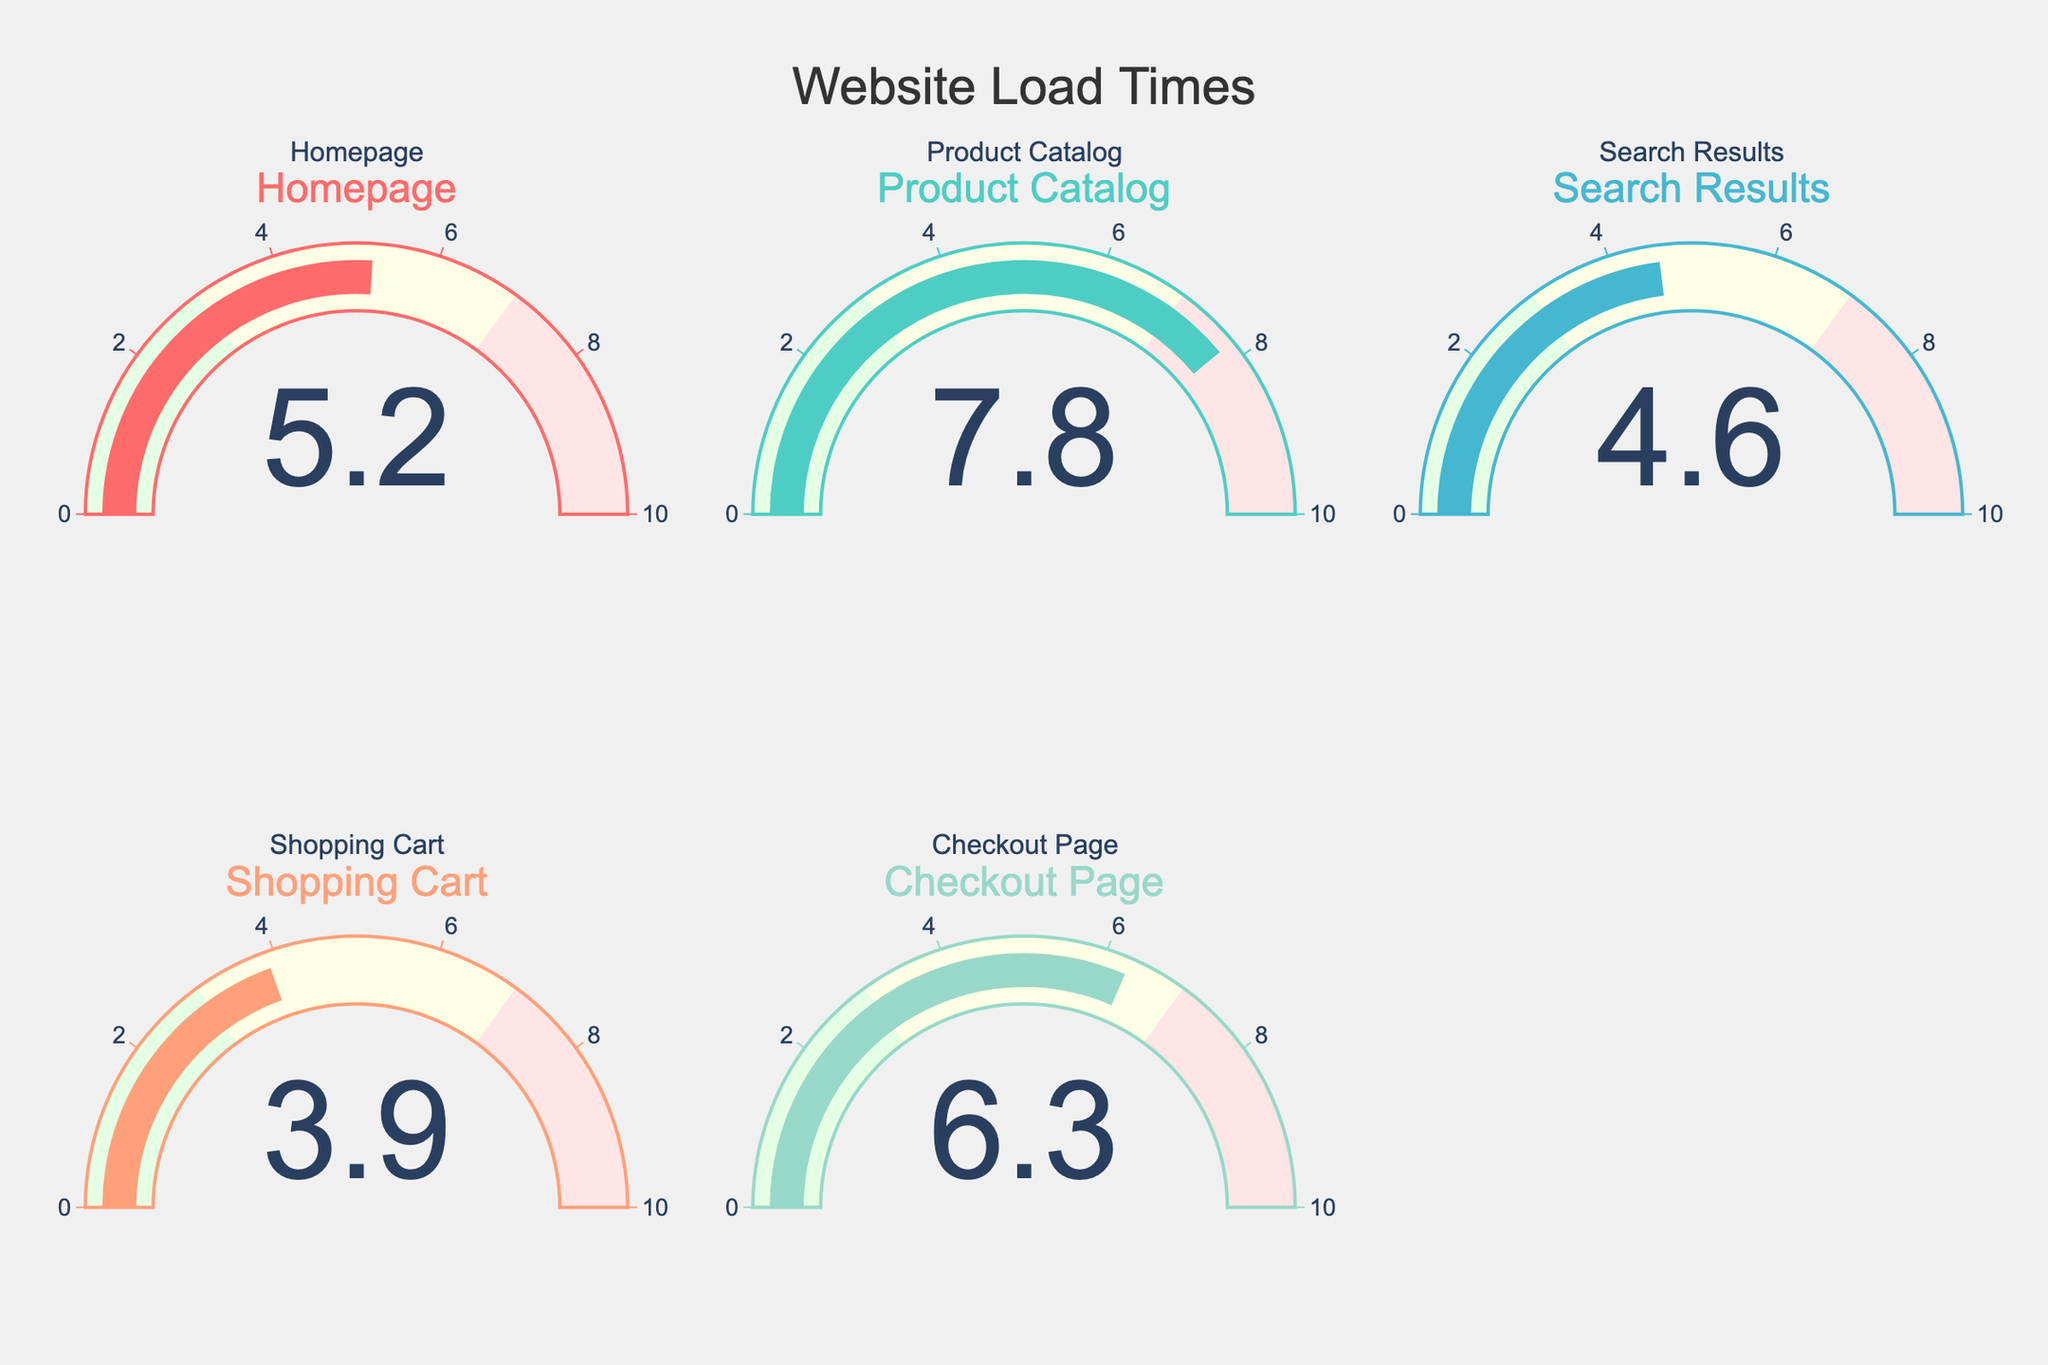What is the load time for the Homepage? The load time for the Homepage gauge displays a single number that indicates its value.
Answer: 5.2 seconds What is the average load time for all pages? To find the average load time, sum all the load times and divide by the number of pages: (5.2 + 7.8 + 4.6 + 3.9 + 6.3) / 5 = 27.8 / 5.
Answer: 5.56 seconds Which page has the highest load time? Compare the load times displayed on all gauges to identify the maximum value.
Answer: Product Catalog How much faster is the Shopping Cart load time compared to the Checkout Page? Subtract the Checkout Page load time from the Shopping Cart load time: 6.3 - 3.9.
Answer: 2.4 seconds Is the homepage load time within the acceptable range of 0 to 3 seconds? Check the load time value for the Homepage and determine if it falls within the specified range.
Answer: No What is the total load time for the Homepage and Search Results combined? Add the load times for both the Homepage and Search Results: 5.2 + 4.6.
Answer: 9.8 seconds Which page has a load time closest to 5 seconds? Compare the load time of each page to 5 seconds and find the nearest value.
Answer: Homepage How many pages have load times greater than 6 seconds? Count the gauges with load times displaying values greater than 6 seconds.
Answer: Two What range is used to indicate a high load time on the gauges? Identify the range within which load times are considered high based on the color coding in the gauge chart.
Answer: 7 to 10 seconds What color is used for the Product Catalog gauge? Observe the color of the bar in the gauge for the Product Catalog.
Answer: Teal 